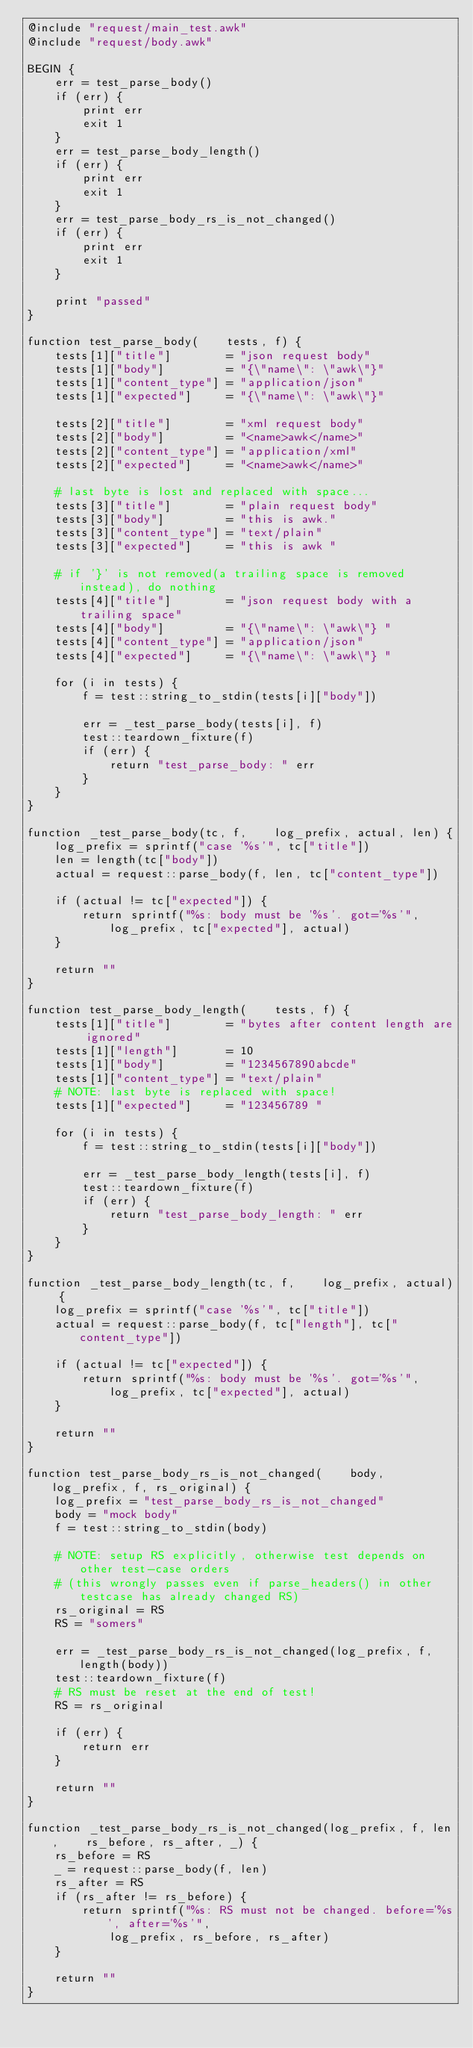<code> <loc_0><loc_0><loc_500><loc_500><_Awk_>@include "request/main_test.awk"
@include "request/body.awk"

BEGIN {
    err = test_parse_body()
    if (err) {
        print err
        exit 1
    }
    err = test_parse_body_length()
    if (err) {
        print err
        exit 1
    }
    err = test_parse_body_rs_is_not_changed()
    if (err) {
        print err
        exit 1
    }

    print "passed"
}

function test_parse_body(    tests, f) {
    tests[1]["title"]        = "json request body"
    tests[1]["body"]         = "{\"name\": \"awk\"}"
    tests[1]["content_type"] = "application/json"
    tests[1]["expected"]     = "{\"name\": \"awk\"}"

    tests[2]["title"]        = "xml request body"
    tests[2]["body"]         = "<name>awk</name>"
    tests[2]["content_type"] = "application/xml"
    tests[2]["expected"]     = "<name>awk</name>"

    # last byte is lost and replaced with space...
    tests[3]["title"]        = "plain request body"
    tests[3]["body"]         = "this is awk."
    tests[3]["content_type"] = "text/plain"
    tests[3]["expected"]     = "this is awk "

    # if '}' is not removed(a trailing space is removed instead), do nothing
    tests[4]["title"]        = "json request body with a trailing space"
    tests[4]["body"]         = "{\"name\": \"awk\"} "
    tests[4]["content_type"] = "application/json"
    tests[4]["expected"]     = "{\"name\": \"awk\"} "

    for (i in tests) {
        f = test::string_to_stdin(tests[i]["body"])

        err = _test_parse_body(tests[i], f)
        test::teardown_fixture(f)
        if (err) {
            return "test_parse_body: " err
        }
    }
}

function _test_parse_body(tc, f,    log_prefix, actual, len) {
    log_prefix = sprintf("case '%s'", tc["title"])
    len = length(tc["body"])
    actual = request::parse_body(f, len, tc["content_type"])

    if (actual != tc["expected"]) {
        return sprintf("%s: body must be '%s'. got='%s'",
            log_prefix, tc["expected"], actual)
    }

    return ""
}

function test_parse_body_length(    tests, f) {
    tests[1]["title"]        = "bytes after content length are ignored"
    tests[1]["length"]       = 10
    tests[1]["body"]         = "1234567890abcde"
    tests[1]["content_type"] = "text/plain"
    # NOTE: last byte is replaced with space!
    tests[1]["expected"]     = "123456789 "

    for (i in tests) {
        f = test::string_to_stdin(tests[i]["body"])

        err = _test_parse_body_length(tests[i], f)
        test::teardown_fixture(f)
        if (err) {
            return "test_parse_body_length: " err
        }
    }
}

function _test_parse_body_length(tc, f,    log_prefix, actual) {
    log_prefix = sprintf("case '%s'", tc["title"])
    actual = request::parse_body(f, tc["length"], tc["content_type"])

    if (actual != tc["expected"]) {
        return sprintf("%s: body must be '%s'. got='%s'",
            log_prefix, tc["expected"], actual)
    }

    return ""
}

function test_parse_body_rs_is_not_changed(    body, log_prefix, f, rs_original) {
    log_prefix = "test_parse_body_rs_is_not_changed"
    body = "mock body"
    f = test::string_to_stdin(body)

    # NOTE: setup RS explicitly, otherwise test depends on other test-case orders
    # (this wrongly passes even if parse_headers() in other testcase has already changed RS)
    rs_original = RS
    RS = "somers"

    err = _test_parse_body_rs_is_not_changed(log_prefix, f, length(body))
    test::teardown_fixture(f)
    # RS must be reset at the end of test!
    RS = rs_original

    if (err) {
        return err
    }

    return ""
}

function _test_parse_body_rs_is_not_changed(log_prefix, f, len,    rs_before, rs_after, _) {
    rs_before = RS
    _ = request::parse_body(f, len)
    rs_after = RS
    if (rs_after != rs_before) {
        return sprintf("%s: RS must not be changed. before='%s', after='%s'",
            log_prefix, rs_before, rs_after)
    }

    return ""
}
</code> 